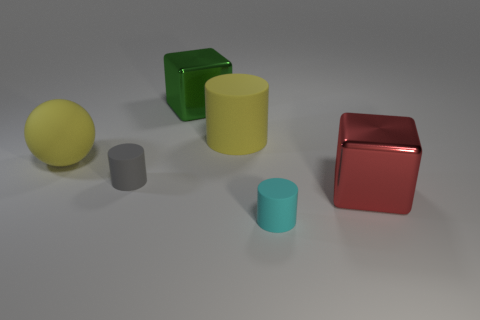There is a cylinder on the left side of the block that is left of the yellow thing that is to the right of the gray matte thing; what size is it?
Ensure brevity in your answer.  Small. What number of other objects are the same material as the green block?
Provide a short and direct response. 1. There is a metal block in front of the large green metal block; what is its size?
Ensure brevity in your answer.  Large. What number of large things are on the left side of the gray cylinder and to the right of the cyan matte object?
Offer a terse response. 0. What material is the cube that is to the left of the big yellow thing that is behind the yellow matte ball?
Offer a terse response. Metal. What is the material of the large red object that is the same shape as the green shiny thing?
Give a very brief answer. Metal. Is there a yellow cylinder?
Your response must be concise. Yes. What is the shape of the small gray thing that is made of the same material as the cyan thing?
Provide a short and direct response. Cylinder. There is a big block on the left side of the tiny cyan matte object; what is its material?
Give a very brief answer. Metal. There is a small matte thing that is behind the large red metal cube; is it the same color as the big rubber cylinder?
Provide a short and direct response. No. 